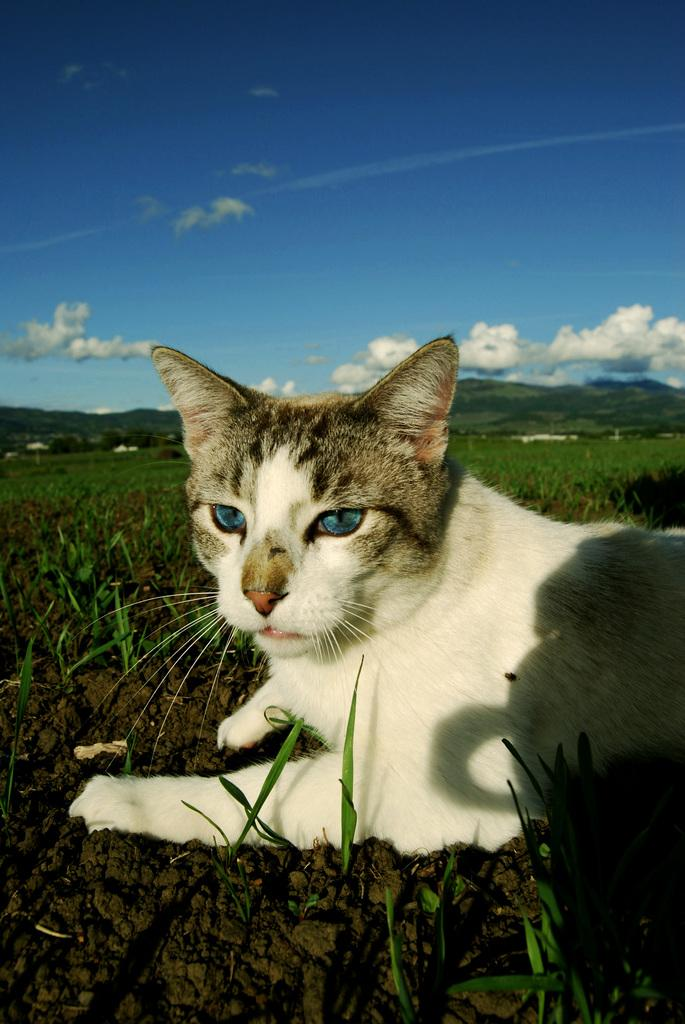What animal can be seen in the image? There is a cat in the image. Where is the cat located? The cat is sitting on the grass. What can be seen in the distance in the image? There are mountains visible in the background of the image. What is present in the sky in the image? Clouds are present in the sky. What type of leather can be seen bursting out of the cat's mitten in the image? There is no leather, bursting, or mitten present in the image; it features a cat sitting on the grass with mountains and clouds in the background. 